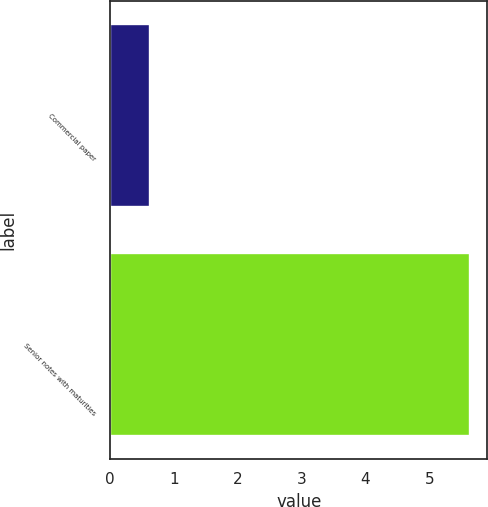<chart> <loc_0><loc_0><loc_500><loc_500><bar_chart><fcel>Commercial paper<fcel>Senior notes with maturities<nl><fcel>0.62<fcel>5.63<nl></chart> 